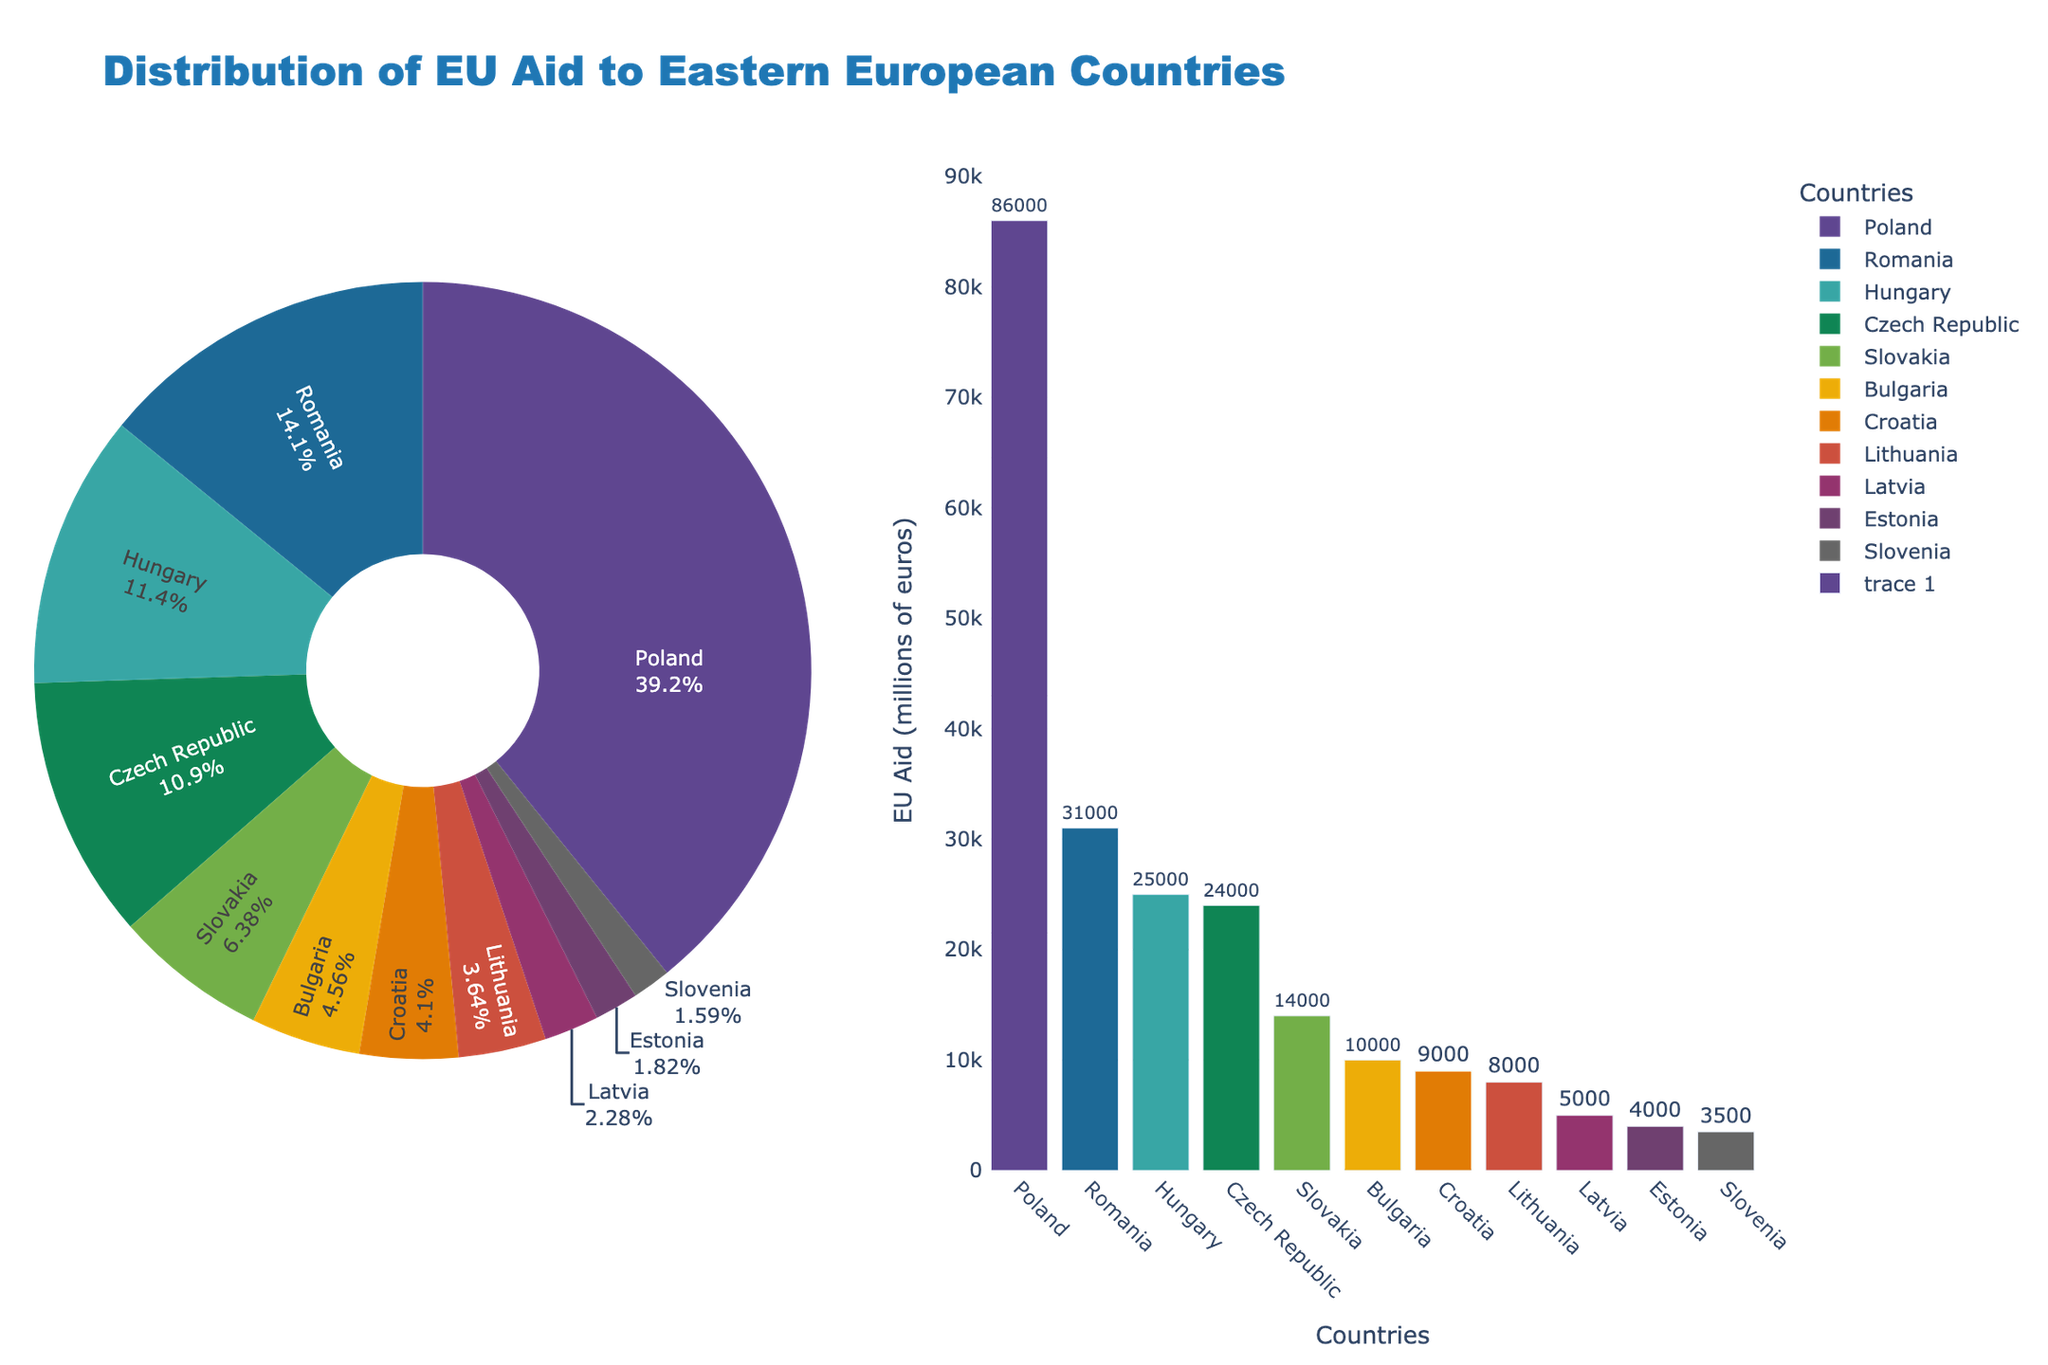Which country receives the largest share of EU aid? Poland receives the largest share, as it has the highest EU aid amount in the pie chart.
Answer: Poland What percentage of total EU aid goes to Romania? Find Romania's share in the pie chart, which indicates the percentage.
Answer: 16% How much more EU aid does Poland receive compared to Hungary? Poland receives 86,000 million euros and Hungary receives 25,000 million euros. The difference is 86,000 - 25,000 = 61,000 million euros.
Answer: 61,000 million euros Which country receives the least amount of EU aid? In the bar chart, Estonia has the smallest bar, indicating it receives the least amount of EU aid.
Answer: Estonia Is the total EU aid for Croatia, Lithuania, and Latvia more or less than the total aid for Hungary? Sum the EU aid for Croatia (9,000), Lithuania (8,000), and Latvia (5,000) which totals to 22,000. Hungary receives 25,000, so the total for these three countries is less than Hungary's.
Answer: Less What is the total EU aid received by Slovakia and Bulgaria combined? Slovakia receives 14,000 million euros and Bulgaria receives 10,000 million euros. The combined amount is 14,000 + 10,000 = 24,000 million euros.
Answer: 24,000 million euros Which countries receive a higher amount of EU aid compared to Slovakia? Based on the bar chart, the countries receiving more than 14,000 million euros are Poland, Romania, Hungary, and Czech Republic.
Answer: Poland, Romania, Hungary, Czech Republic What is the combined percentage of EU aid for Latvia and Estonia? Find the percentages for Latvia and Estonia in the pie chart and sum them up.
Answer: 5% + 4% = 9% How many countries receive less EU aid than Bulgaria? From the bar chart, Croatia, Lithuania, Latvia, Estonia, and Slovenia all receive less than 10,000 million euros, totaling 5 countries.
Answer: 5 countries What is the average EU aid received by Czech Republic, Bulgaria, and Slovenia? The amounts are 24,000 (Czech Republic), 10,000 (Bulgaria), and 3,500 (Slovenia). The sum is 24,000 + 10,000 + 3,500 = 37,500. The average is 37,500 / 3 = 12,500 million euros.
Answer: 12,500 million euros 